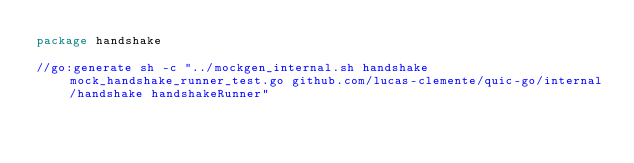Convert code to text. <code><loc_0><loc_0><loc_500><loc_500><_Go_>package handshake

//go:generate sh -c "../mockgen_internal.sh handshake mock_handshake_runner_test.go github.com/lucas-clemente/quic-go/internal/handshake handshakeRunner"
</code> 